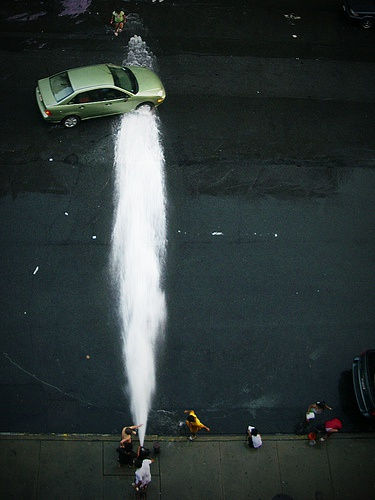Describe the objects in this image and their specific colors. I can see car in black, green, darkgreen, and darkgray tones, car in black, purple, teal, and darkblue tones, people in black, darkgray, and gray tones, people in black, maroon, olive, and brown tones, and people in black, maroon, and gray tones in this image. 